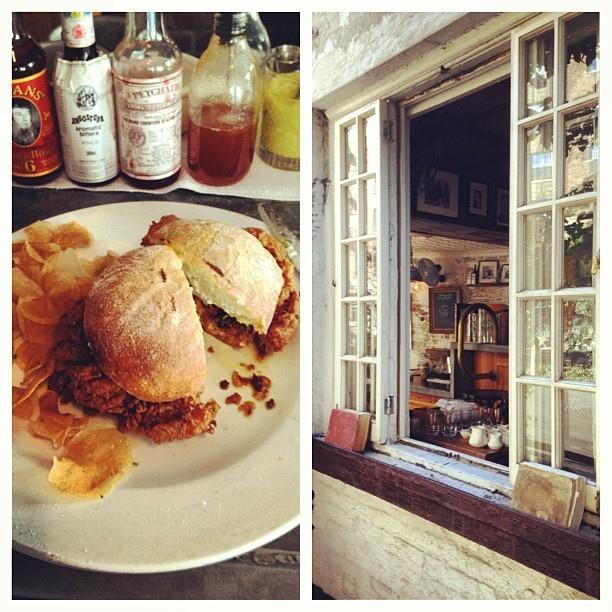How many bottles are visible in the left picture?
Give a very brief answer. 4. How many bottles are there?
Give a very brief answer. 4. How many sandwiches are there?
Give a very brief answer. 2. 